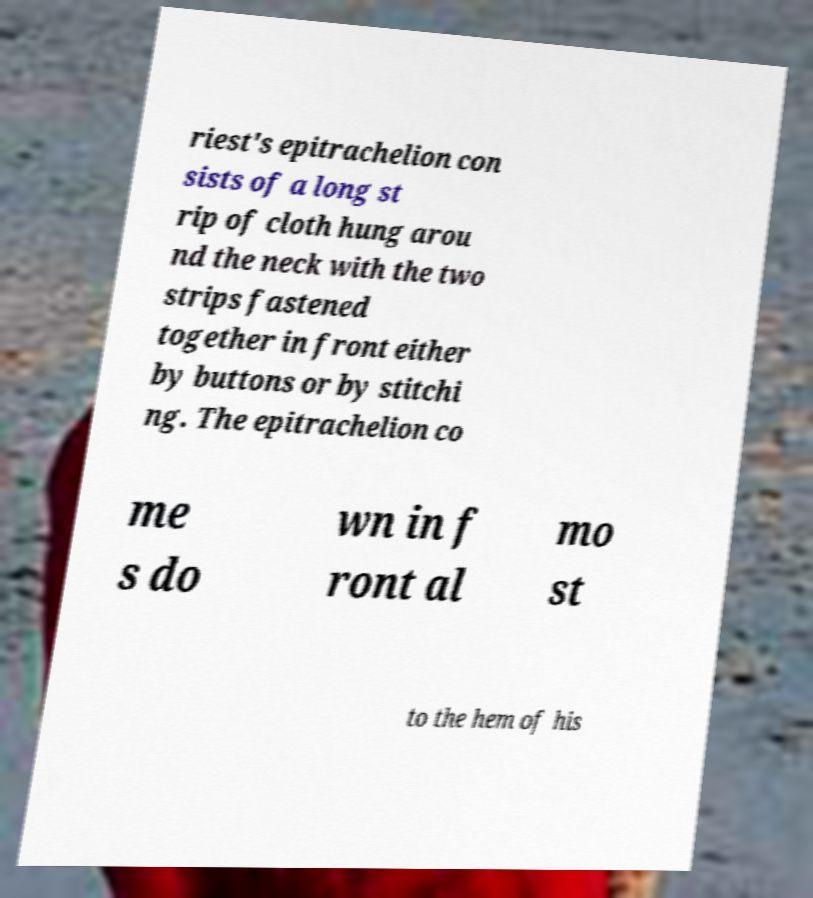There's text embedded in this image that I need extracted. Can you transcribe it verbatim? riest's epitrachelion con sists of a long st rip of cloth hung arou nd the neck with the two strips fastened together in front either by buttons or by stitchi ng. The epitrachelion co me s do wn in f ront al mo st to the hem of his 